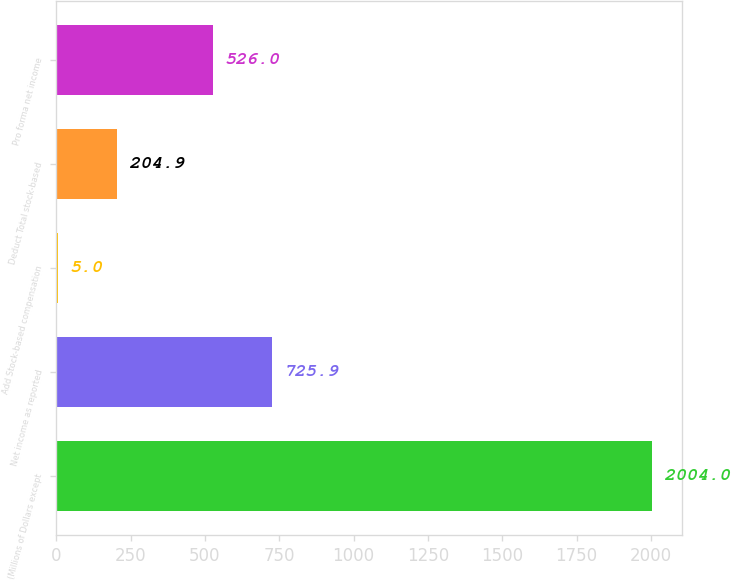Convert chart to OTSL. <chart><loc_0><loc_0><loc_500><loc_500><bar_chart><fcel>(Millions of Dollars except<fcel>Net income as reported<fcel>Add Stock-based compensation<fcel>Deduct Total stock-based<fcel>Pro forma net income<nl><fcel>2004<fcel>725.9<fcel>5<fcel>204.9<fcel>526<nl></chart> 